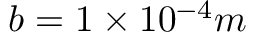Convert formula to latex. <formula><loc_0><loc_0><loc_500><loc_500>b = 1 \times 1 0 ^ { - 4 } m</formula> 